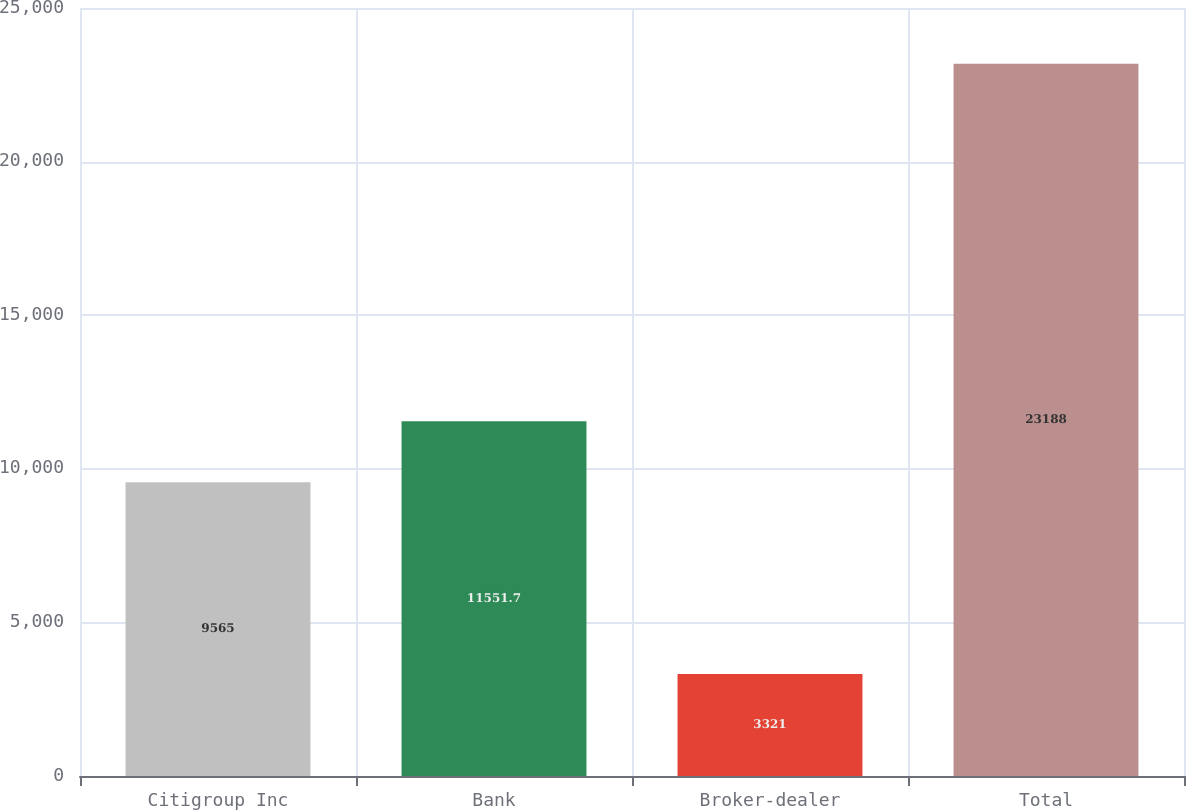Convert chart to OTSL. <chart><loc_0><loc_0><loc_500><loc_500><bar_chart><fcel>Citigroup Inc<fcel>Bank<fcel>Broker-dealer<fcel>Total<nl><fcel>9565<fcel>11551.7<fcel>3321<fcel>23188<nl></chart> 